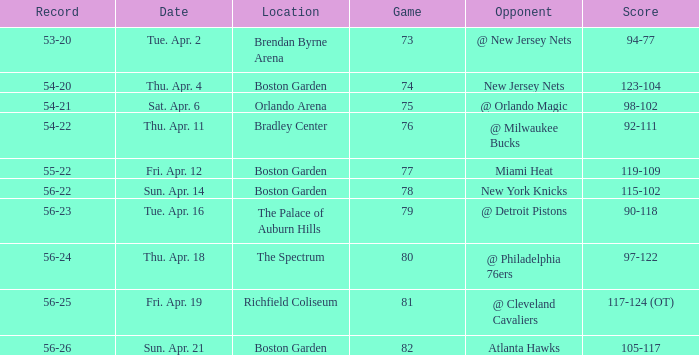Which Score has a Location of richfield coliseum? 117-124 (OT). 